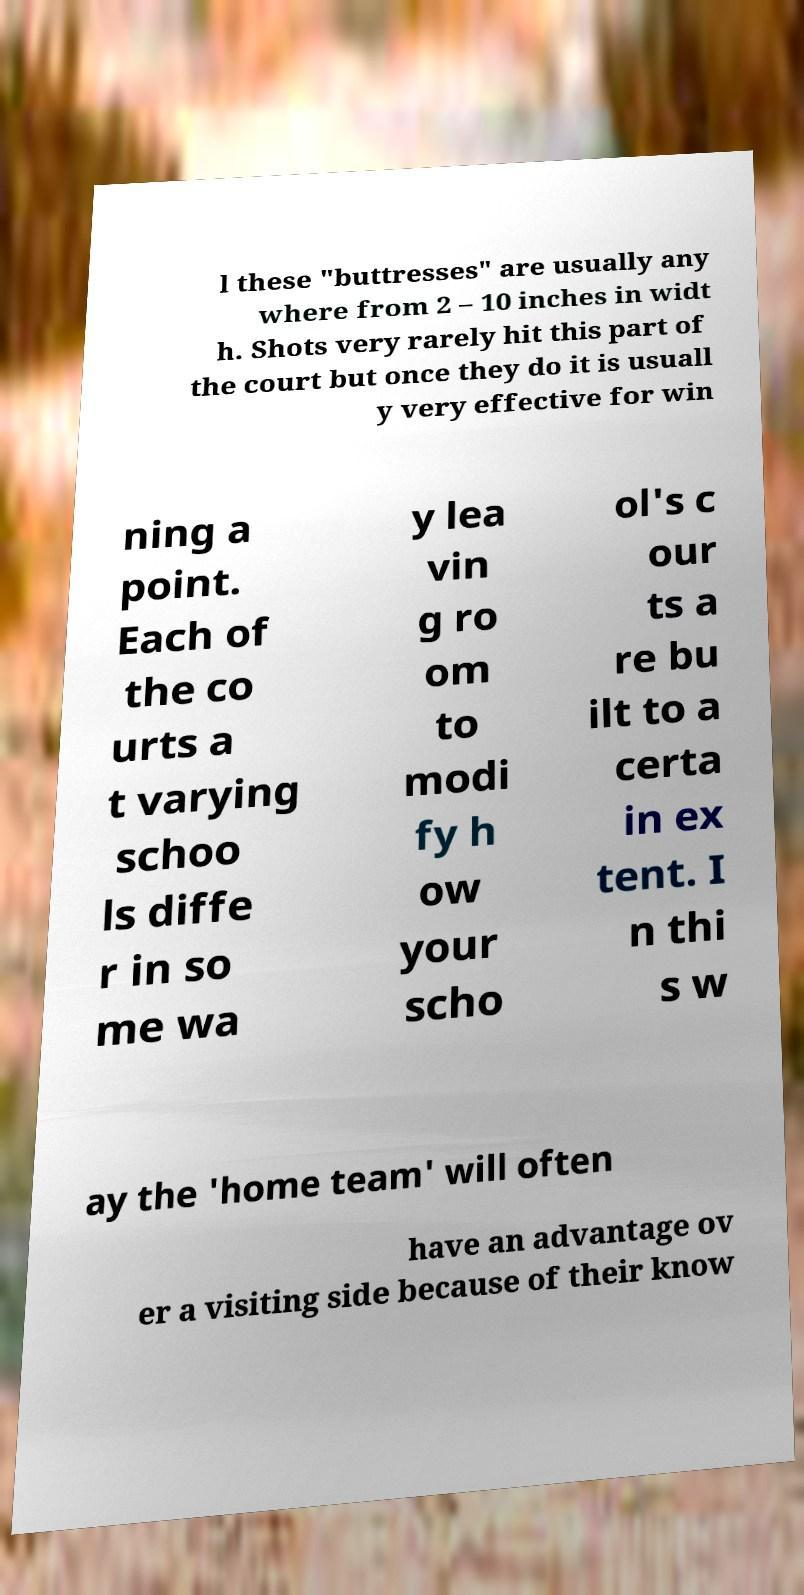What messages or text are displayed in this image? I need them in a readable, typed format. l these "buttresses" are usually any where from 2 – 10 inches in widt h. Shots very rarely hit this part of the court but once they do it is usuall y very effective for win ning a point. Each of the co urts a t varying schoo ls diffe r in so me wa y lea vin g ro om to modi fy h ow your scho ol's c our ts a re bu ilt to a certa in ex tent. I n thi s w ay the 'home team' will often have an advantage ov er a visiting side because of their know 